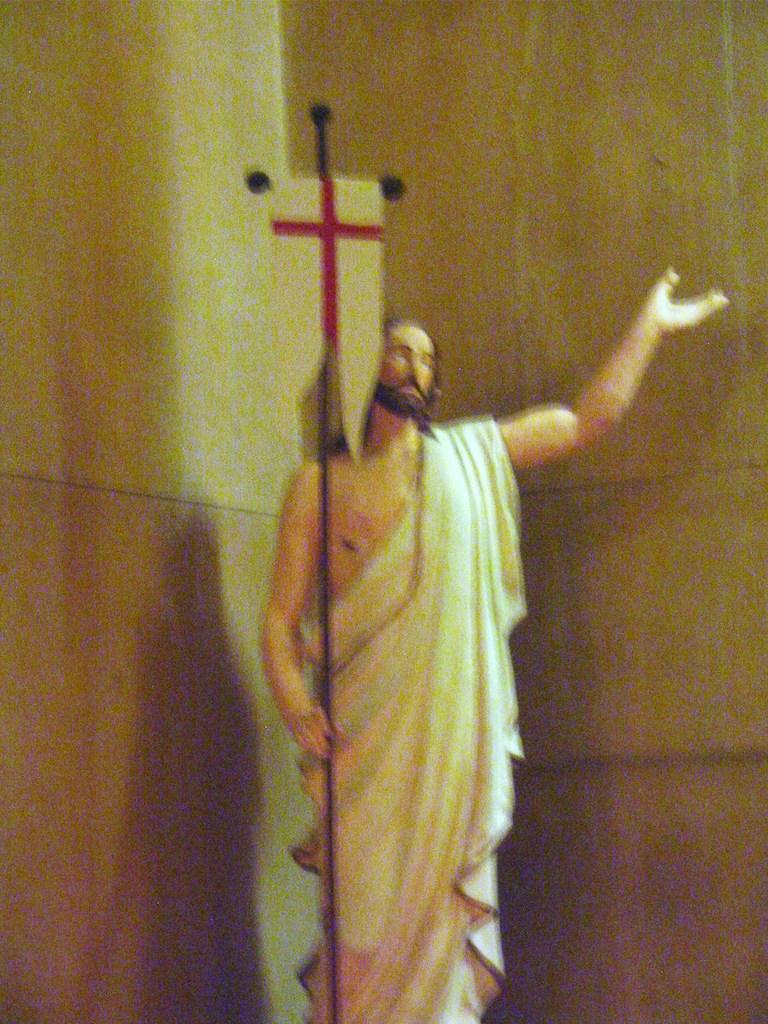What is the main subject in the image? There is a statue in the image. What else can be seen in the image besides the statue? There is a wall in the image. What type of shirt is the statue wearing in the image? The statue is not wearing a shirt, as it is a non-living object and does not have clothing. 